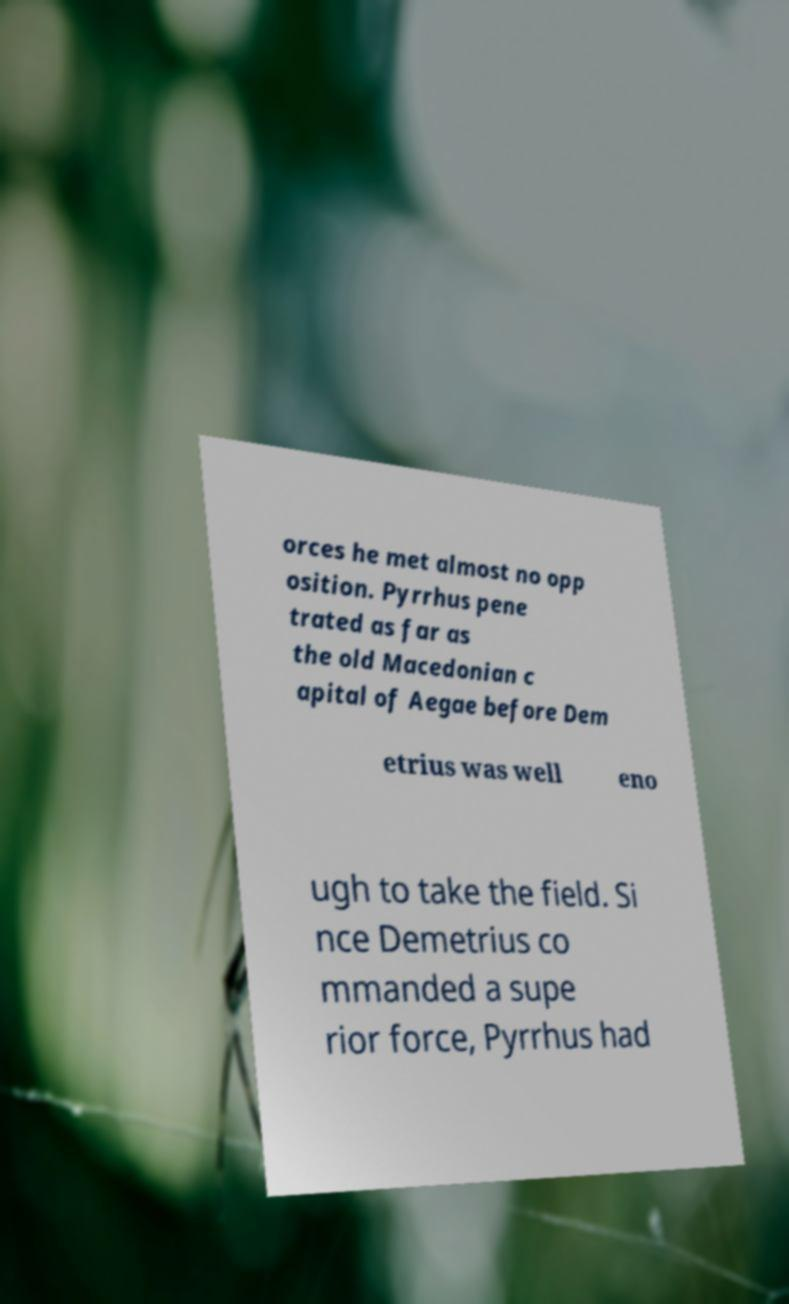Could you extract and type out the text from this image? orces he met almost no opp osition. Pyrrhus pene trated as far as the old Macedonian c apital of Aegae before Dem etrius was well eno ugh to take the field. Si nce Demetrius co mmanded a supe rior force, Pyrrhus had 